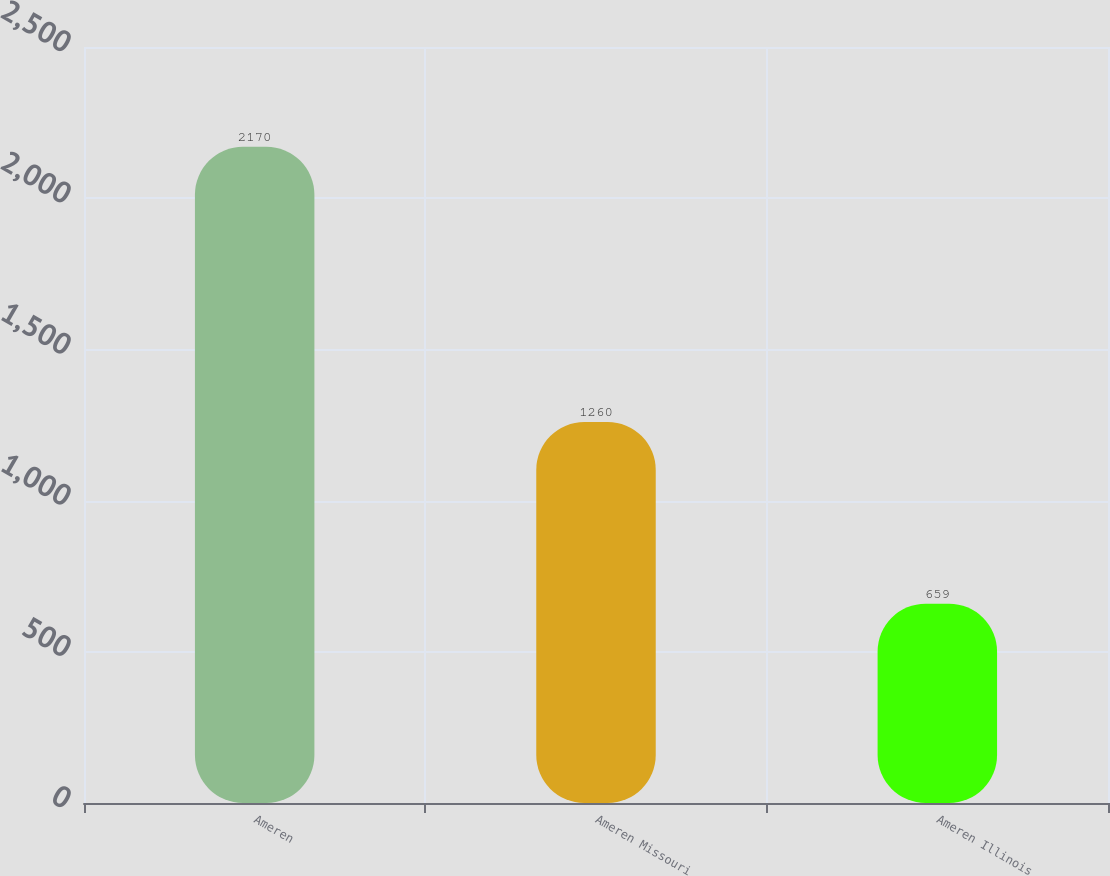Convert chart. <chart><loc_0><loc_0><loc_500><loc_500><bar_chart><fcel>Ameren<fcel>Ameren Missouri<fcel>Ameren Illinois<nl><fcel>2170<fcel>1260<fcel>659<nl></chart> 